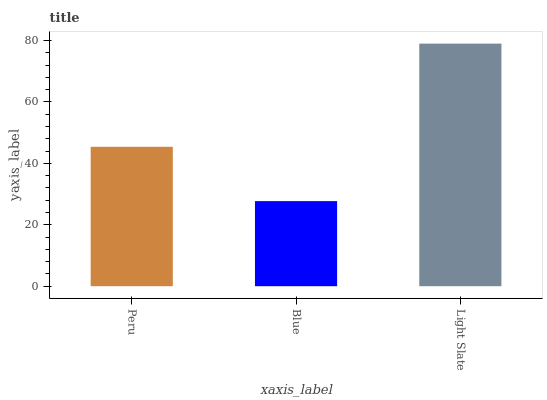Is Blue the minimum?
Answer yes or no. Yes. Is Light Slate the maximum?
Answer yes or no. Yes. Is Light Slate the minimum?
Answer yes or no. No. Is Blue the maximum?
Answer yes or no. No. Is Light Slate greater than Blue?
Answer yes or no. Yes. Is Blue less than Light Slate?
Answer yes or no. Yes. Is Blue greater than Light Slate?
Answer yes or no. No. Is Light Slate less than Blue?
Answer yes or no. No. Is Peru the high median?
Answer yes or no. Yes. Is Peru the low median?
Answer yes or no. Yes. Is Blue the high median?
Answer yes or no. No. Is Light Slate the low median?
Answer yes or no. No. 